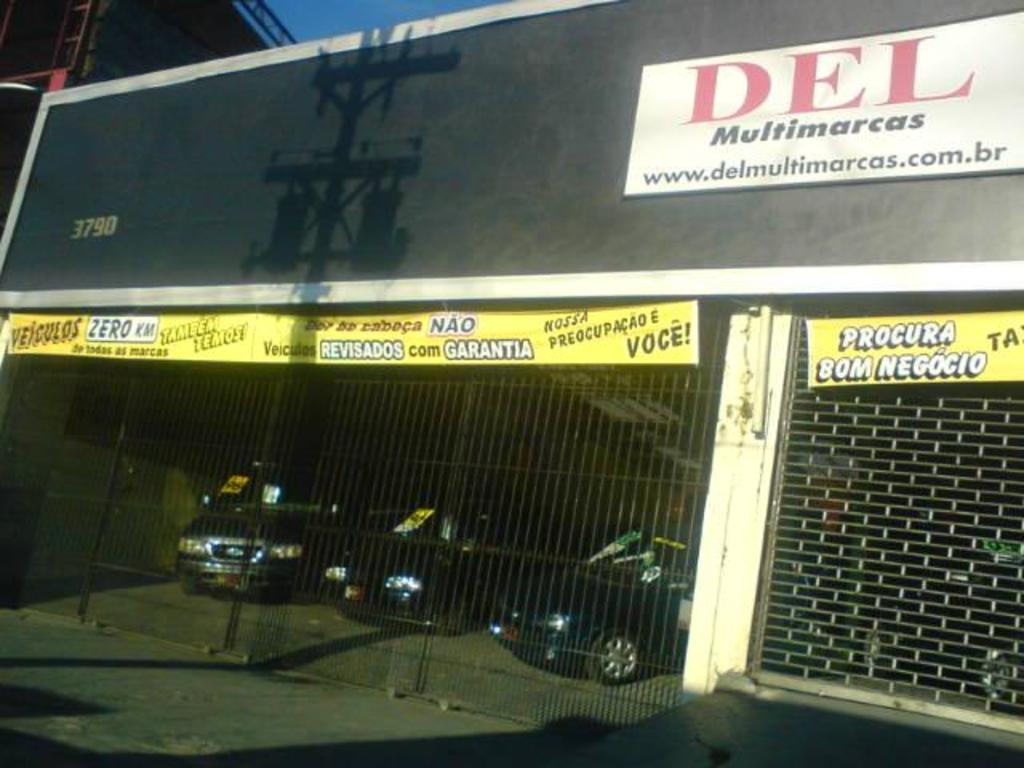Please provide a concise description of this image. In this picture we can see a name board, banners, shutter, vehicles on the ground, fence and some objects. 